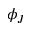<formula> <loc_0><loc_0><loc_500><loc_500>\phi _ { J }</formula> 